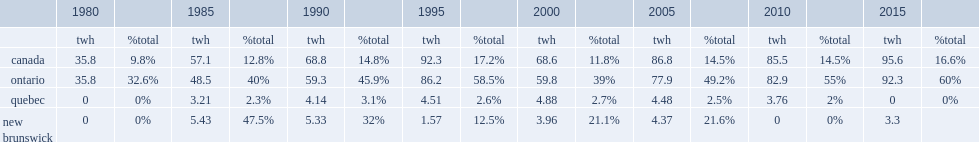Nuclear power in canada is producing a total of 95.6 terawatt-hours (twh) of electricity. 95.6. Parse the full table. {'header': ['', '1980', '', '1985', '', '1990', '', '1995', '', '2000', '', '2005', '', '2010', '', '2015', ''], 'rows': [['', 'twh', '%total', 'twh', '%total', 'twh', '%total', 'twh', '%total', 'twh', '%total', 'twh', '%total', 'twh', '%total', 'twh', '%total'], ['canada', '35.8', '9.8%', '57.1', '12.8%', '68.8', '14.8%', '92.3', '17.2%', '68.6', '11.8%', '86.8', '14.5%', '85.5', '14.5%', '95.6', '16.6%'], ['ontario', '35.8', '32.6%', '48.5', '40%', '59.3', '45.9%', '86.2', '58.5%', '59.8', '39%', '77.9', '49.2%', '82.9', '55%', '92.3', '60%'], ['quebec', '0', '0%', '3.21', '2.3%', '4.14', '3.1%', '4.51', '2.6%', '4.88', '2.7%', '4.48', '2.5%', '3.76', '2%', '0', '0%'], ['new brunswick', '0', '0%', '5.43', '47.5%', '5.33', '32%', '1.57', '12.5%', '3.96', '21.1%', '4.37', '21.6%', '0', '0%', '3.3', '']]} 